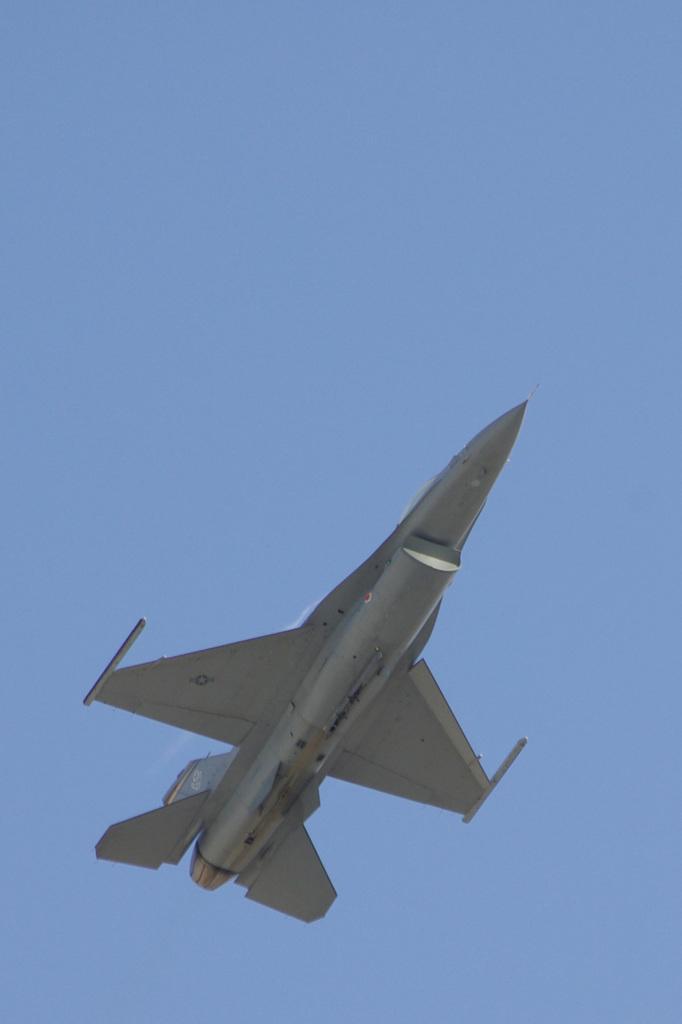How would you summarize this image in a sentence or two? In this picture we can see an aircraft flying, in the background there is sky. 